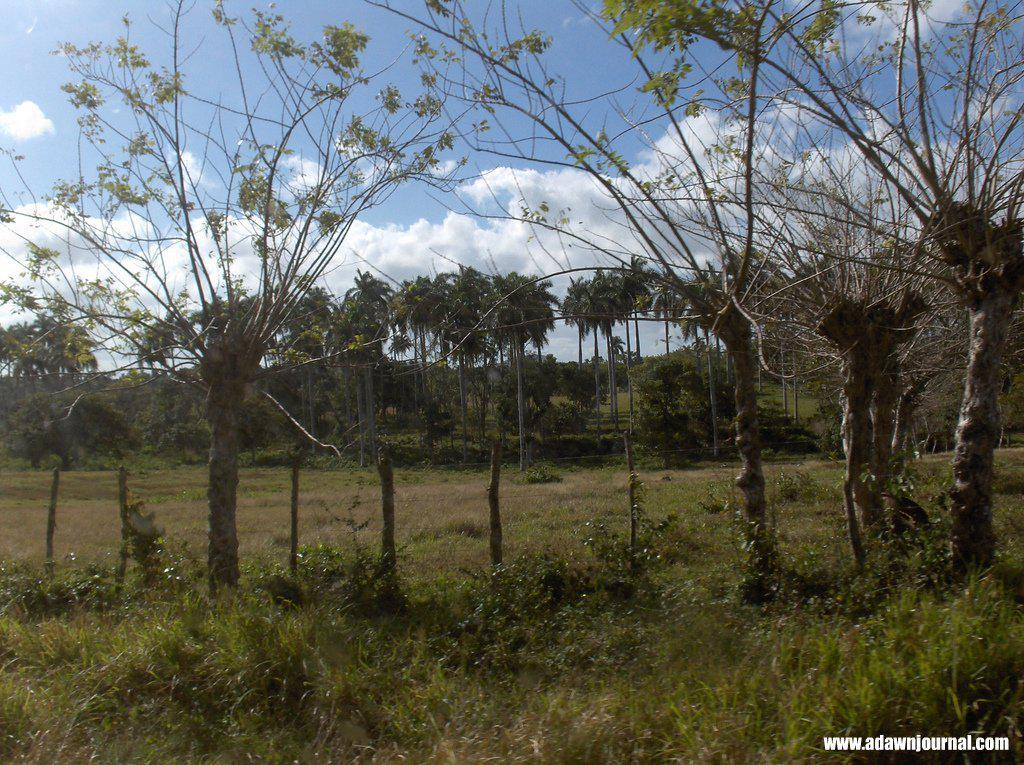What type of vegetation can be seen in the image? There are trees, plants, and grass in the image. What is visible in the background of the image? The sky is visible in the background of the image. Can you describe the ground in the image? The ground is covered with grass in the image. Is there any text or marking in the image? Yes, there is a watermark in the bottom right corner of the image. What type of toothpaste is being used to fill the hole in the image? There is no toothpaste or hole present in the image. What is the source of shame in the image? There is no shame or any indication of shame in the image. 